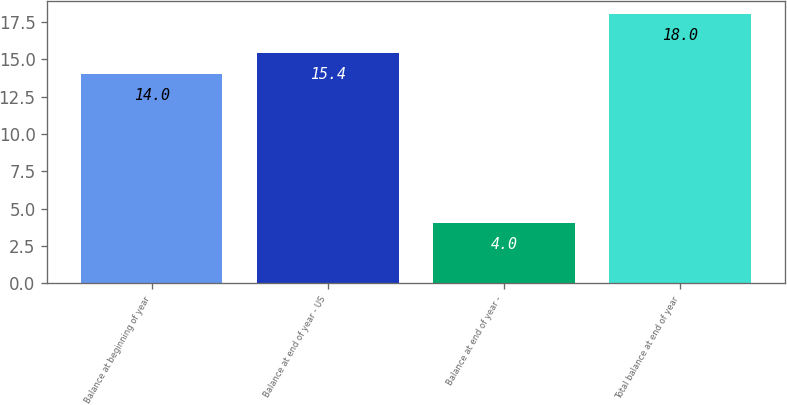Convert chart. <chart><loc_0><loc_0><loc_500><loc_500><bar_chart><fcel>Balance at beginning of year<fcel>Balance at end of year - US<fcel>Balance at end of year -<fcel>Total balance at end of year<nl><fcel>14<fcel>15.4<fcel>4<fcel>18<nl></chart> 